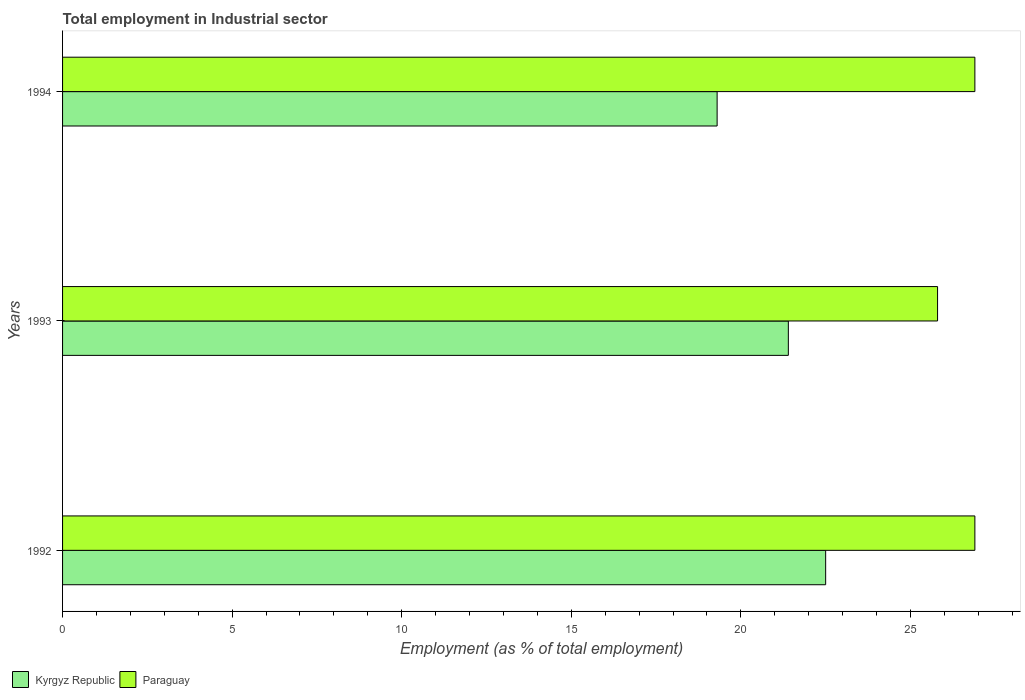How many groups of bars are there?
Keep it short and to the point. 3. Are the number of bars on each tick of the Y-axis equal?
Offer a very short reply. Yes. How many bars are there on the 2nd tick from the bottom?
Offer a terse response. 2. What is the label of the 3rd group of bars from the top?
Offer a very short reply. 1992. What is the employment in industrial sector in Kyrgyz Republic in 1994?
Give a very brief answer. 19.3. Across all years, what is the maximum employment in industrial sector in Paraguay?
Your response must be concise. 26.9. Across all years, what is the minimum employment in industrial sector in Kyrgyz Republic?
Give a very brief answer. 19.3. In which year was the employment in industrial sector in Kyrgyz Republic maximum?
Ensure brevity in your answer.  1992. What is the total employment in industrial sector in Kyrgyz Republic in the graph?
Offer a very short reply. 63.2. What is the difference between the employment in industrial sector in Paraguay in 1992 and that in 1993?
Make the answer very short. 1.1. What is the difference between the employment in industrial sector in Paraguay in 1994 and the employment in industrial sector in Kyrgyz Republic in 1993?
Keep it short and to the point. 5.5. What is the average employment in industrial sector in Kyrgyz Republic per year?
Make the answer very short. 21.07. In the year 1992, what is the difference between the employment in industrial sector in Paraguay and employment in industrial sector in Kyrgyz Republic?
Offer a very short reply. 4.4. What is the ratio of the employment in industrial sector in Kyrgyz Republic in 1992 to that in 1993?
Keep it short and to the point. 1.05. What is the difference between the highest and the lowest employment in industrial sector in Paraguay?
Give a very brief answer. 1.1. In how many years, is the employment in industrial sector in Kyrgyz Republic greater than the average employment in industrial sector in Kyrgyz Republic taken over all years?
Provide a succinct answer. 2. Is the sum of the employment in industrial sector in Paraguay in 1992 and 1993 greater than the maximum employment in industrial sector in Kyrgyz Republic across all years?
Offer a terse response. Yes. What does the 1st bar from the top in 1993 represents?
Ensure brevity in your answer.  Paraguay. What does the 1st bar from the bottom in 1992 represents?
Ensure brevity in your answer.  Kyrgyz Republic. How many years are there in the graph?
Offer a terse response. 3. Are the values on the major ticks of X-axis written in scientific E-notation?
Provide a succinct answer. No. Does the graph contain any zero values?
Ensure brevity in your answer.  No. Does the graph contain grids?
Provide a short and direct response. No. Where does the legend appear in the graph?
Your answer should be very brief. Bottom left. What is the title of the graph?
Make the answer very short. Total employment in Industrial sector. What is the label or title of the X-axis?
Your answer should be compact. Employment (as % of total employment). What is the label or title of the Y-axis?
Your response must be concise. Years. What is the Employment (as % of total employment) of Kyrgyz Republic in 1992?
Keep it short and to the point. 22.5. What is the Employment (as % of total employment) of Paraguay in 1992?
Keep it short and to the point. 26.9. What is the Employment (as % of total employment) in Kyrgyz Republic in 1993?
Give a very brief answer. 21.4. What is the Employment (as % of total employment) of Paraguay in 1993?
Offer a very short reply. 25.8. What is the Employment (as % of total employment) in Kyrgyz Republic in 1994?
Make the answer very short. 19.3. What is the Employment (as % of total employment) of Paraguay in 1994?
Give a very brief answer. 26.9. Across all years, what is the maximum Employment (as % of total employment) in Paraguay?
Your answer should be compact. 26.9. Across all years, what is the minimum Employment (as % of total employment) of Kyrgyz Republic?
Keep it short and to the point. 19.3. Across all years, what is the minimum Employment (as % of total employment) in Paraguay?
Offer a very short reply. 25.8. What is the total Employment (as % of total employment) in Kyrgyz Republic in the graph?
Provide a short and direct response. 63.2. What is the total Employment (as % of total employment) in Paraguay in the graph?
Ensure brevity in your answer.  79.6. What is the difference between the Employment (as % of total employment) in Kyrgyz Republic in 1992 and that in 1994?
Give a very brief answer. 3.2. What is the difference between the Employment (as % of total employment) of Paraguay in 1992 and that in 1994?
Your answer should be compact. 0. What is the difference between the Employment (as % of total employment) of Kyrgyz Republic in 1993 and that in 1994?
Keep it short and to the point. 2.1. What is the difference between the Employment (as % of total employment) in Kyrgyz Republic in 1992 and the Employment (as % of total employment) in Paraguay in 1993?
Offer a terse response. -3.3. What is the average Employment (as % of total employment) in Kyrgyz Republic per year?
Your answer should be very brief. 21.07. What is the average Employment (as % of total employment) of Paraguay per year?
Your answer should be very brief. 26.53. In the year 1992, what is the difference between the Employment (as % of total employment) in Kyrgyz Republic and Employment (as % of total employment) in Paraguay?
Provide a succinct answer. -4.4. In the year 1993, what is the difference between the Employment (as % of total employment) in Kyrgyz Republic and Employment (as % of total employment) in Paraguay?
Make the answer very short. -4.4. In the year 1994, what is the difference between the Employment (as % of total employment) of Kyrgyz Republic and Employment (as % of total employment) of Paraguay?
Make the answer very short. -7.6. What is the ratio of the Employment (as % of total employment) in Kyrgyz Republic in 1992 to that in 1993?
Ensure brevity in your answer.  1.05. What is the ratio of the Employment (as % of total employment) of Paraguay in 1992 to that in 1993?
Your answer should be very brief. 1.04. What is the ratio of the Employment (as % of total employment) of Kyrgyz Republic in 1992 to that in 1994?
Give a very brief answer. 1.17. What is the ratio of the Employment (as % of total employment) of Kyrgyz Republic in 1993 to that in 1994?
Give a very brief answer. 1.11. What is the ratio of the Employment (as % of total employment) in Paraguay in 1993 to that in 1994?
Give a very brief answer. 0.96. What is the difference between the highest and the lowest Employment (as % of total employment) of Paraguay?
Give a very brief answer. 1.1. 